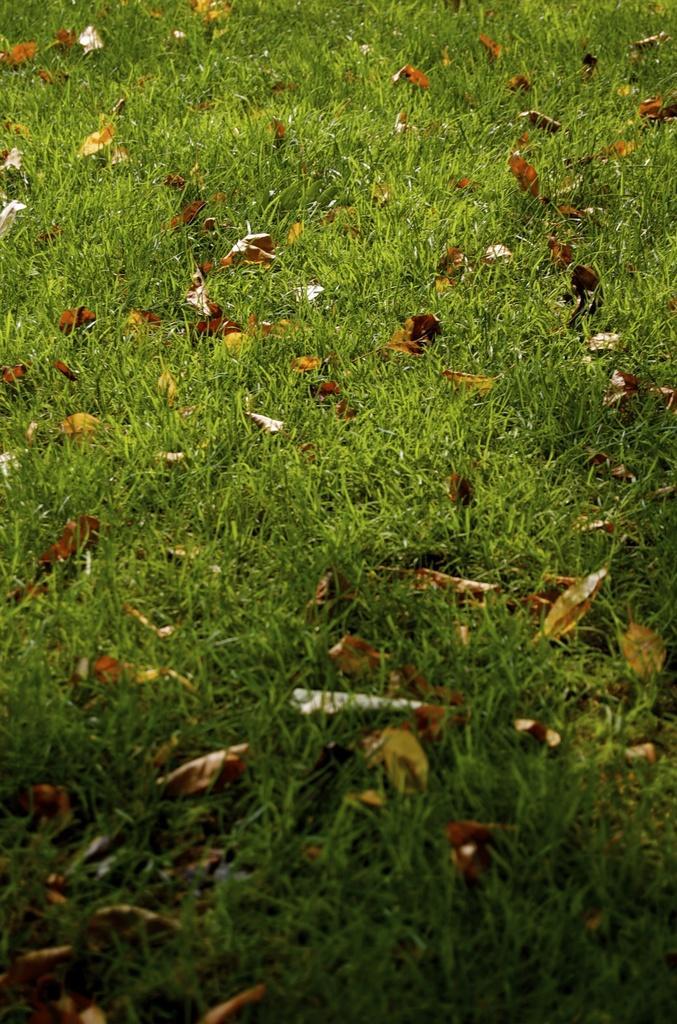Could you give a brief overview of what you see in this image? In this image there are dried leaves and grass on the ground. 